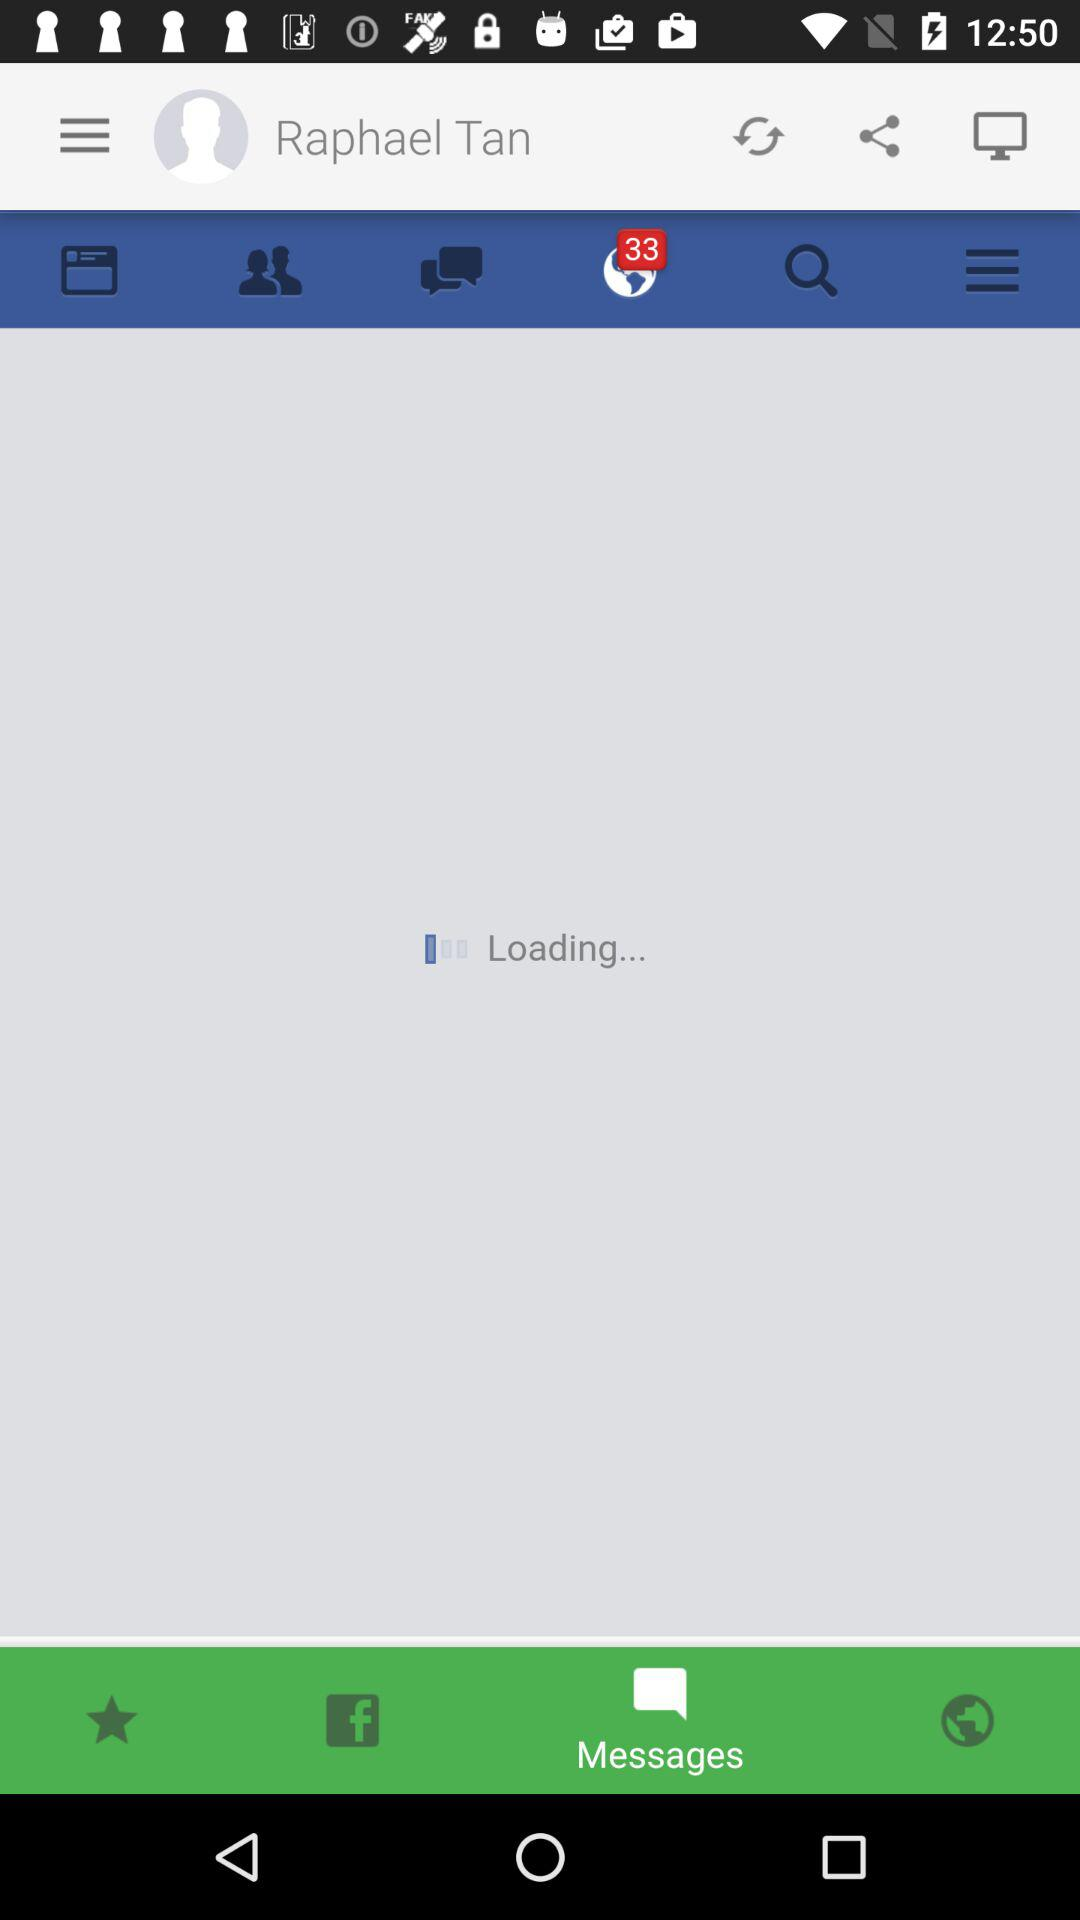What is the user name? The user name is Raphael Tan. 